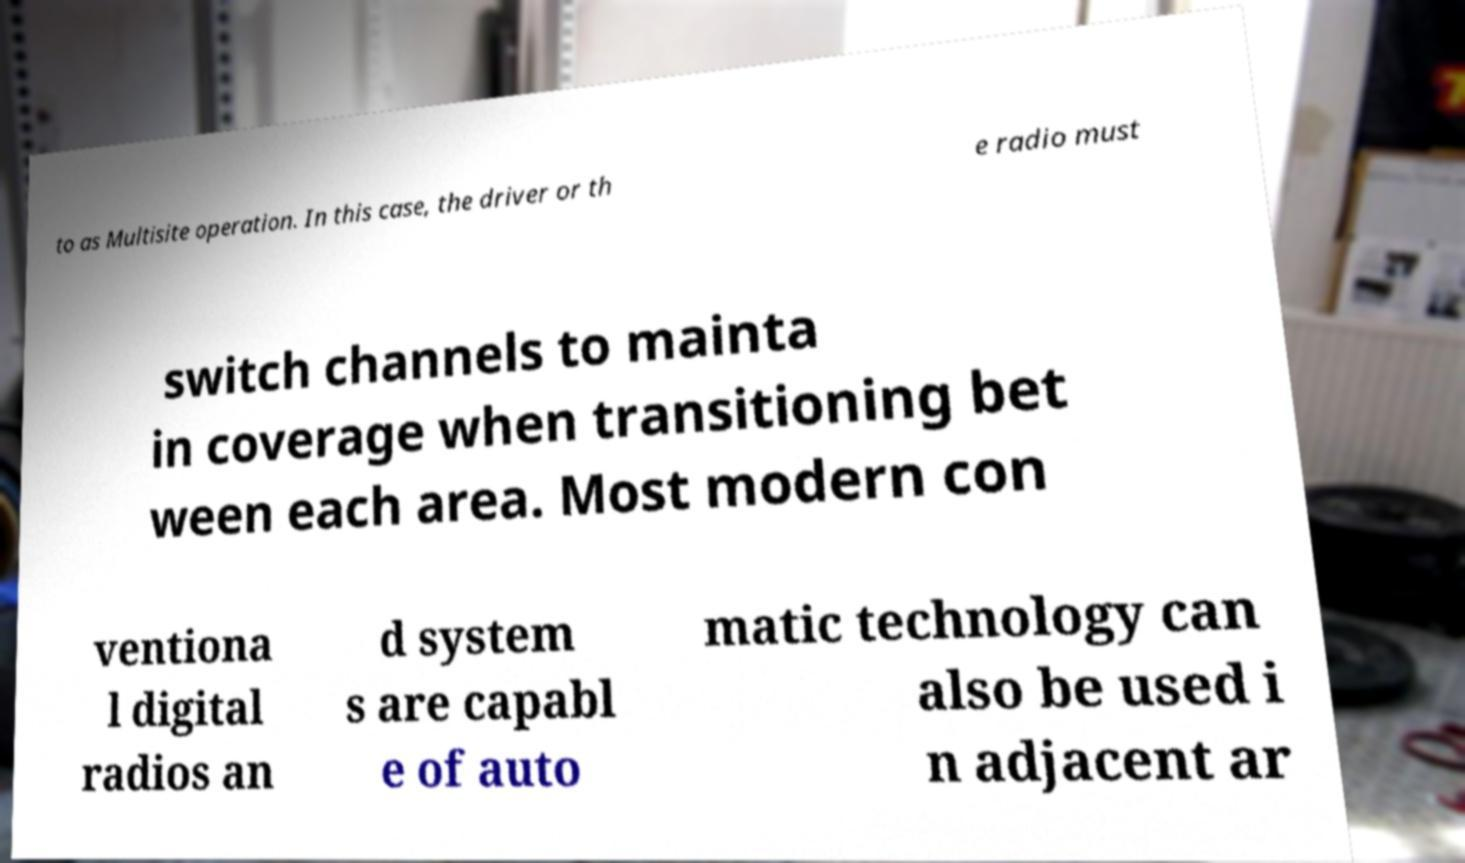Can you accurately transcribe the text from the provided image for me? to as Multisite operation. In this case, the driver or th e radio must switch channels to mainta in coverage when transitioning bet ween each area. Most modern con ventiona l digital radios an d system s are capabl e of auto matic technology can also be used i n adjacent ar 